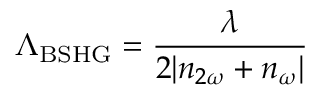<formula> <loc_0><loc_0><loc_500><loc_500>\Lambda _ { B S H G } = \frac { \lambda } { 2 | n _ { 2 \omega } + n _ { \omega } | }</formula> 